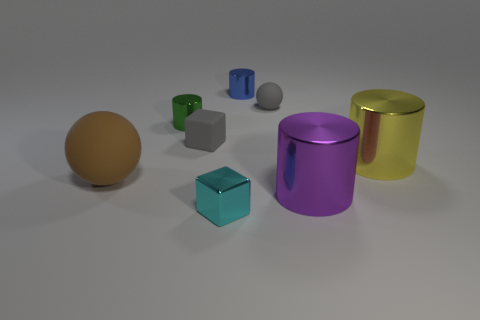What size is the rubber thing that is the same color as the tiny matte cube?
Ensure brevity in your answer.  Small. There is a gray ball that is the same size as the blue metallic cylinder; what is its material?
Give a very brief answer. Rubber. Does the green metallic cylinder have the same size as the matte ball in front of the big yellow metallic cylinder?
Ensure brevity in your answer.  No. What material is the tiny object that is on the right side of the blue metal cylinder?
Your answer should be very brief. Rubber. Is the number of objects in front of the small matte sphere the same as the number of gray matte blocks?
Offer a very short reply. No. Is the shiny cube the same size as the green thing?
Give a very brief answer. Yes. Is there a matte thing that is behind the tiny matte object that is in front of the ball behind the rubber cube?
Provide a short and direct response. Yes. What is the material of the blue object that is the same shape as the large purple thing?
Offer a very short reply. Metal. What number of tiny gray spheres are on the left side of the tiny gray object left of the tiny cyan metallic cube?
Provide a succinct answer. 0. How big is the matte sphere that is in front of the tiny gray thing right of the tiny metal cylinder behind the green shiny thing?
Provide a short and direct response. Large. 